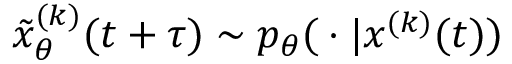<formula> <loc_0><loc_0><loc_500><loc_500>\tilde { x } _ { \theta } ^ { ( k ) } ( t + \tau ) \sim p _ { \theta } | x ^ { ( k ) } ( t ) )</formula> 